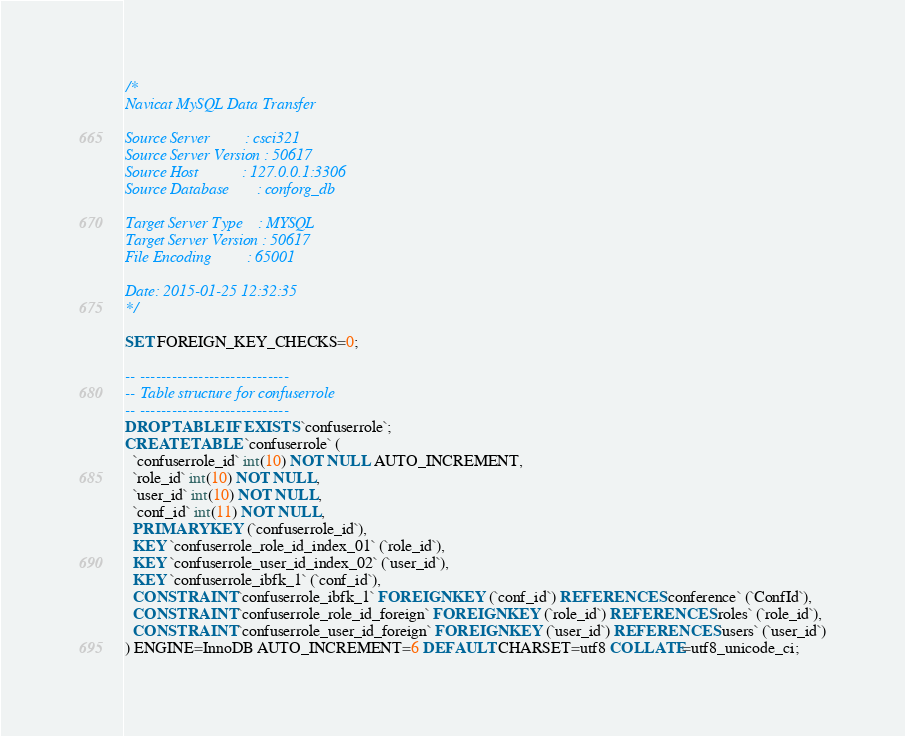Convert code to text. <code><loc_0><loc_0><loc_500><loc_500><_SQL_>/*
Navicat MySQL Data Transfer

Source Server         : csci321
Source Server Version : 50617
Source Host           : 127.0.0.1:3306
Source Database       : conforg_db

Target Server Type    : MYSQL
Target Server Version : 50617
File Encoding         : 65001

Date: 2015-01-25 12:32:35
*/

SET FOREIGN_KEY_CHECKS=0;

-- ----------------------------
-- Table structure for confuserrole
-- ----------------------------
DROP TABLE IF EXISTS `confuserrole`;
CREATE TABLE `confuserrole` (
  `confuserrole_id` int(10) NOT NULL AUTO_INCREMENT,
  `role_id` int(10) NOT NULL,
  `user_id` int(10) NOT NULL,
  `conf_id` int(11) NOT NULL,
  PRIMARY KEY (`confuserrole_id`),
  KEY `confuserrole_role_id_index_01` (`role_id`),
  KEY `confuserrole_user_id_index_02` (`user_id`),
  KEY `confuserrole_ibfk_1` (`conf_id`),
  CONSTRAINT `confuserrole_ibfk_1` FOREIGN KEY (`conf_id`) REFERENCES `conference` (`ConfId`),
  CONSTRAINT `confuserrole_role_id_foreign` FOREIGN KEY (`role_id`) REFERENCES `roles` (`role_id`),
  CONSTRAINT `confuserrole_user_id_foreign` FOREIGN KEY (`user_id`) REFERENCES `users` (`user_id`)
) ENGINE=InnoDB AUTO_INCREMENT=6 DEFAULT CHARSET=utf8 COLLATE=utf8_unicode_ci;
</code> 